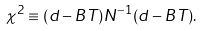<formula> <loc_0><loc_0><loc_500><loc_500>\chi ^ { 2 } \equiv ( d - B T ) N ^ { - 1 } ( d - B T ) .</formula> 